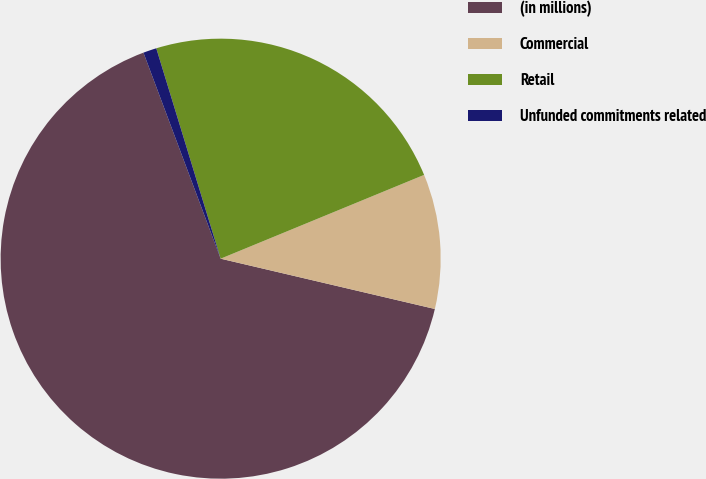Convert chart to OTSL. <chart><loc_0><loc_0><loc_500><loc_500><pie_chart><fcel>(in millions)<fcel>Commercial<fcel>Retail<fcel>Unfunded commitments related<nl><fcel>65.63%<fcel>9.89%<fcel>23.51%<fcel>0.98%<nl></chart> 